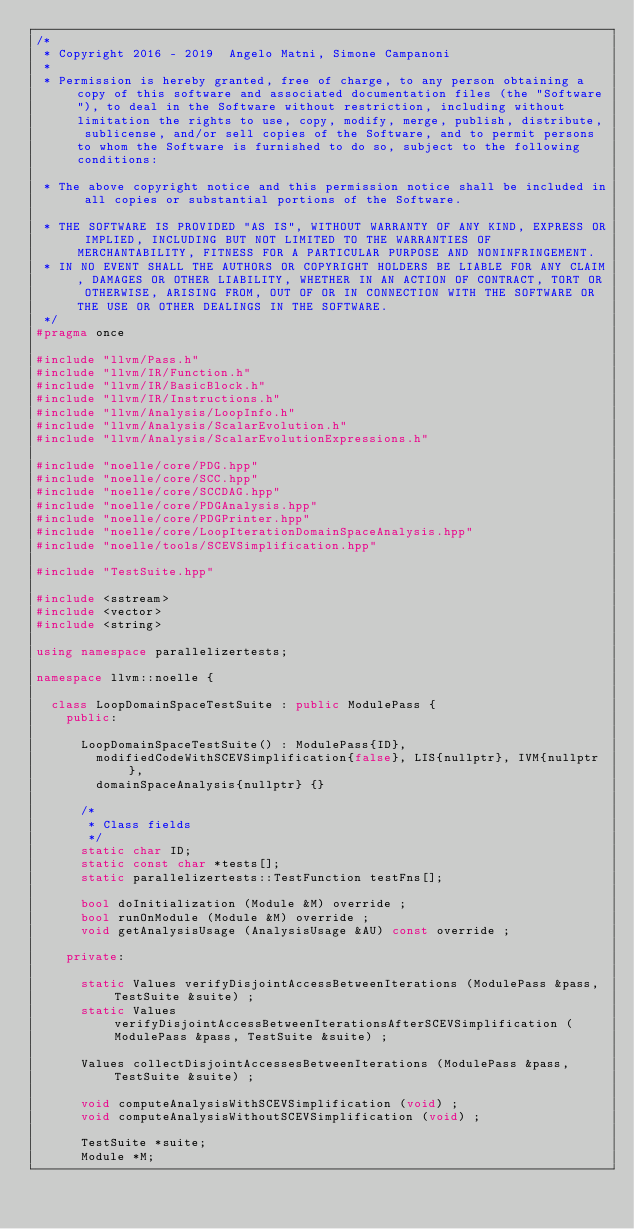<code> <loc_0><loc_0><loc_500><loc_500><_C++_>/*
 * Copyright 2016 - 2019  Angelo Matni, Simone Campanoni
 *
 * Permission is hereby granted, free of charge, to any person obtaining a copy of this software and associated documentation files (the "Software"), to deal in the Software without restriction, including without limitation the rights to use, copy, modify, merge, publish, distribute, sublicense, and/or sell copies of the Software, and to permit persons to whom the Software is furnished to do so, subject to the following conditions:

 * The above copyright notice and this permission notice shall be included in all copies or substantial portions of the Software.

 * THE SOFTWARE IS PROVIDED "AS IS", WITHOUT WARRANTY OF ANY KIND, EXPRESS OR IMPLIED, INCLUDING BUT NOT LIMITED TO THE WARRANTIES OF MERCHANTABILITY, FITNESS FOR A PARTICULAR PURPOSE AND NONINFRINGEMENT. 
 * IN NO EVENT SHALL THE AUTHORS OR COPYRIGHT HOLDERS BE LIABLE FOR ANY CLAIM, DAMAGES OR OTHER LIABILITY, WHETHER IN AN ACTION OF CONTRACT, TORT OR OTHERWISE, ARISING FROM, OUT OF OR IN CONNECTION WITH THE SOFTWARE OR THE USE OR OTHER DEALINGS IN THE SOFTWARE.
 */
#pragma once

#include "llvm/Pass.h"
#include "llvm/IR/Function.h"
#include "llvm/IR/BasicBlock.h"
#include "llvm/IR/Instructions.h"
#include "llvm/Analysis/LoopInfo.h"
#include "llvm/Analysis/ScalarEvolution.h"
#include "llvm/Analysis/ScalarEvolutionExpressions.h"

#include "noelle/core/PDG.hpp"
#include "noelle/core/SCC.hpp"
#include "noelle/core/SCCDAG.hpp"
#include "noelle/core/PDGAnalysis.hpp"
#include "noelle/core/PDGPrinter.hpp"
#include "noelle/core/LoopIterationDomainSpaceAnalysis.hpp"
#include "noelle/tools/SCEVSimplification.hpp"

#include "TestSuite.hpp"

#include <sstream>
#include <vector>
#include <string>

using namespace parallelizertests;

namespace llvm::noelle {

  class LoopDomainSpaceTestSuite : public ModulePass {
    public:

      LoopDomainSpaceTestSuite() : ModulePass{ID},
        modifiedCodeWithSCEVSimplification{false}, LIS{nullptr}, IVM{nullptr},
        domainSpaceAnalysis{nullptr} {}

      /*
       * Class fields
       */
      static char ID;
      static const char *tests[];
      static parallelizertests::TestFunction testFns[];

      bool doInitialization (Module &M) override ;
      bool runOnModule (Module &M) override ;
      void getAnalysisUsage (AnalysisUsage &AU) const override ;

    private:

      static Values verifyDisjointAccessBetweenIterations (ModulePass &pass, TestSuite &suite) ;
      static Values verifyDisjointAccessBetweenIterationsAfterSCEVSimplification (ModulePass &pass, TestSuite &suite) ;

      Values collectDisjointAccessesBetweenIterations (ModulePass &pass, TestSuite &suite) ;

      void computeAnalysisWithSCEVSimplification (void) ;
      void computeAnalysisWithoutSCEVSimplification (void) ;

      TestSuite *suite;
      Module *M;
</code> 